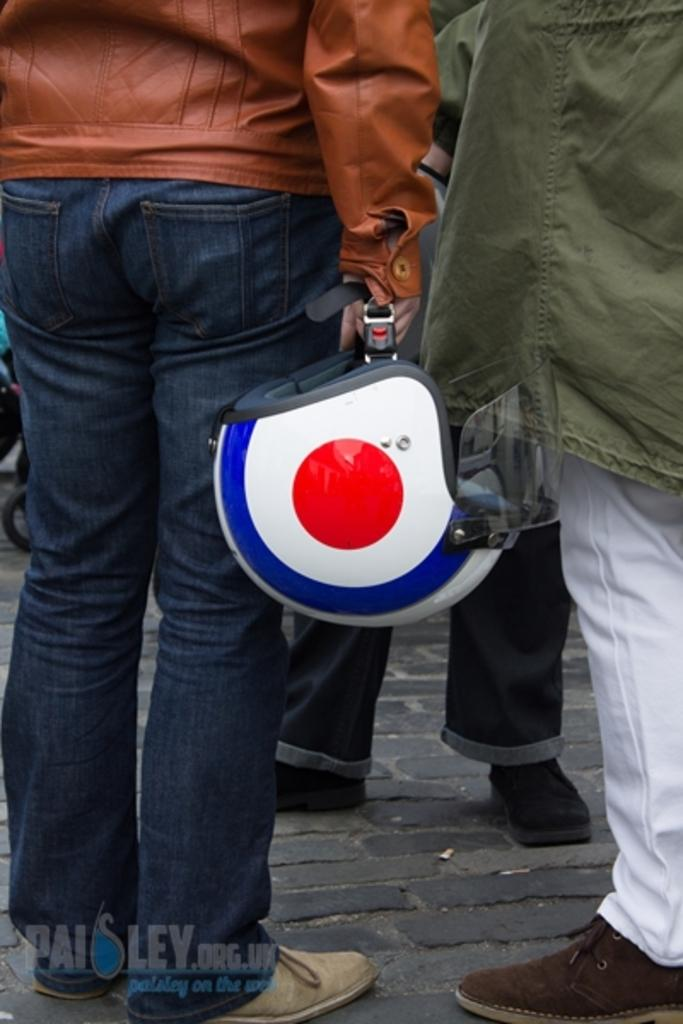What is present in the image? There are people in the image. Can you describe any specific actions or objects being held by the people? Yes, there is a person holding a helmet. What type of hobbies do the people in the image enjoy? There is no information provided about the hobbies of the people in the image. What color is the string used to tie the cream in the image? There is no string or cream present in the image. 